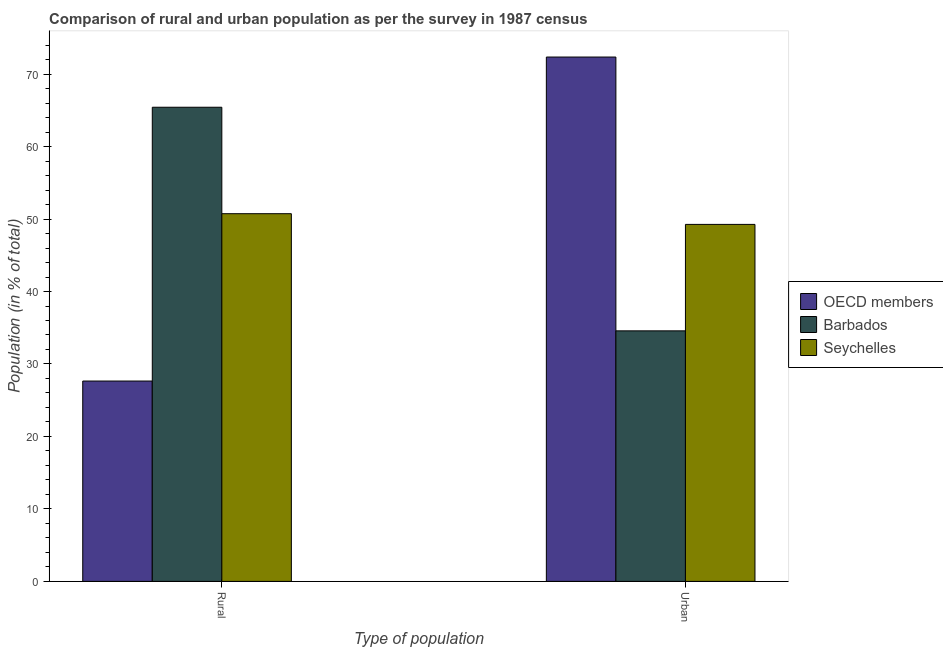How many different coloured bars are there?
Your response must be concise. 3. How many groups of bars are there?
Offer a very short reply. 2. Are the number of bars per tick equal to the number of legend labels?
Offer a terse response. Yes. How many bars are there on the 1st tick from the left?
Ensure brevity in your answer.  3. What is the label of the 2nd group of bars from the left?
Offer a very short reply. Urban. What is the rural population in Seychelles?
Make the answer very short. 50.74. Across all countries, what is the maximum rural population?
Provide a succinct answer. 65.43. Across all countries, what is the minimum rural population?
Your response must be concise. 27.65. In which country was the rural population maximum?
Provide a succinct answer. Barbados. What is the total rural population in the graph?
Your answer should be very brief. 143.81. What is the difference between the urban population in Barbados and that in OECD members?
Your answer should be very brief. -37.78. What is the difference between the rural population in Barbados and the urban population in OECD members?
Provide a short and direct response. -6.93. What is the average rural population per country?
Ensure brevity in your answer.  47.94. What is the difference between the urban population and rural population in Seychelles?
Provide a short and direct response. -1.48. In how many countries, is the rural population greater than 44 %?
Provide a succinct answer. 2. What is the ratio of the rural population in OECD members to that in Barbados?
Keep it short and to the point. 0.42. What does the 2nd bar from the left in Urban represents?
Ensure brevity in your answer.  Barbados. What does the 1st bar from the right in Rural represents?
Offer a terse response. Seychelles. How many bars are there?
Keep it short and to the point. 6. Does the graph contain any zero values?
Your answer should be very brief. No. How many legend labels are there?
Offer a terse response. 3. What is the title of the graph?
Ensure brevity in your answer.  Comparison of rural and urban population as per the survey in 1987 census. What is the label or title of the X-axis?
Provide a succinct answer. Type of population. What is the label or title of the Y-axis?
Give a very brief answer. Population (in % of total). What is the Population (in % of total) in OECD members in Rural?
Your answer should be very brief. 27.65. What is the Population (in % of total) in Barbados in Rural?
Offer a very short reply. 65.43. What is the Population (in % of total) in Seychelles in Rural?
Your response must be concise. 50.74. What is the Population (in % of total) in OECD members in Urban?
Offer a terse response. 72.35. What is the Population (in % of total) of Barbados in Urban?
Keep it short and to the point. 34.57. What is the Population (in % of total) in Seychelles in Urban?
Ensure brevity in your answer.  49.26. Across all Type of population, what is the maximum Population (in % of total) of OECD members?
Your answer should be very brief. 72.35. Across all Type of population, what is the maximum Population (in % of total) of Barbados?
Ensure brevity in your answer.  65.43. Across all Type of population, what is the maximum Population (in % of total) in Seychelles?
Provide a succinct answer. 50.74. Across all Type of population, what is the minimum Population (in % of total) of OECD members?
Give a very brief answer. 27.65. Across all Type of population, what is the minimum Population (in % of total) in Barbados?
Your answer should be very brief. 34.57. Across all Type of population, what is the minimum Population (in % of total) in Seychelles?
Provide a succinct answer. 49.26. What is the total Population (in % of total) in OECD members in the graph?
Your response must be concise. 100. What is the total Population (in % of total) of Barbados in the graph?
Your response must be concise. 100. What is the total Population (in % of total) of Seychelles in the graph?
Provide a short and direct response. 100. What is the difference between the Population (in % of total) in OECD members in Rural and that in Urban?
Provide a succinct answer. -44.71. What is the difference between the Population (in % of total) of Barbados in Rural and that in Urban?
Offer a terse response. 30.86. What is the difference between the Population (in % of total) of Seychelles in Rural and that in Urban?
Your answer should be compact. 1.48. What is the difference between the Population (in % of total) in OECD members in Rural and the Population (in % of total) in Barbados in Urban?
Your answer should be very brief. -6.93. What is the difference between the Population (in % of total) of OECD members in Rural and the Population (in % of total) of Seychelles in Urban?
Offer a terse response. -21.62. What is the difference between the Population (in % of total) of Barbados in Rural and the Population (in % of total) of Seychelles in Urban?
Your answer should be compact. 16.17. What is the average Population (in % of total) of Barbados per Type of population?
Your response must be concise. 50. What is the average Population (in % of total) in Seychelles per Type of population?
Provide a succinct answer. 50. What is the difference between the Population (in % of total) in OECD members and Population (in % of total) in Barbados in Rural?
Keep it short and to the point. -37.78. What is the difference between the Population (in % of total) in OECD members and Population (in % of total) in Seychelles in Rural?
Your answer should be compact. -23.09. What is the difference between the Population (in % of total) in Barbados and Population (in % of total) in Seychelles in Rural?
Your response must be concise. 14.69. What is the difference between the Population (in % of total) of OECD members and Population (in % of total) of Barbados in Urban?
Ensure brevity in your answer.  37.78. What is the difference between the Population (in % of total) in OECD members and Population (in % of total) in Seychelles in Urban?
Give a very brief answer. 23.09. What is the difference between the Population (in % of total) in Barbados and Population (in % of total) in Seychelles in Urban?
Give a very brief answer. -14.69. What is the ratio of the Population (in % of total) of OECD members in Rural to that in Urban?
Provide a short and direct response. 0.38. What is the ratio of the Population (in % of total) of Barbados in Rural to that in Urban?
Your response must be concise. 1.89. What is the difference between the highest and the second highest Population (in % of total) of OECD members?
Your answer should be compact. 44.71. What is the difference between the highest and the second highest Population (in % of total) of Barbados?
Make the answer very short. 30.86. What is the difference between the highest and the second highest Population (in % of total) of Seychelles?
Provide a short and direct response. 1.48. What is the difference between the highest and the lowest Population (in % of total) in OECD members?
Make the answer very short. 44.71. What is the difference between the highest and the lowest Population (in % of total) of Barbados?
Keep it short and to the point. 30.86. What is the difference between the highest and the lowest Population (in % of total) in Seychelles?
Provide a short and direct response. 1.48. 